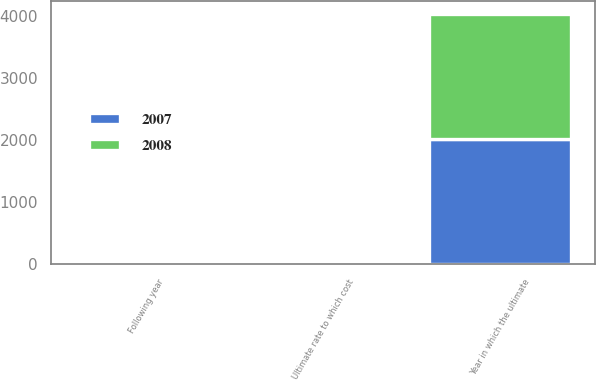<chart> <loc_0><loc_0><loc_500><loc_500><stacked_bar_chart><ecel><fcel>Following year<fcel>Ultimate rate to which cost<fcel>Year in which the ultimate<nl><fcel>2007<fcel>7.5<fcel>5<fcel>2014<nl><fcel>2008<fcel>8<fcel>5<fcel>2014<nl></chart> 